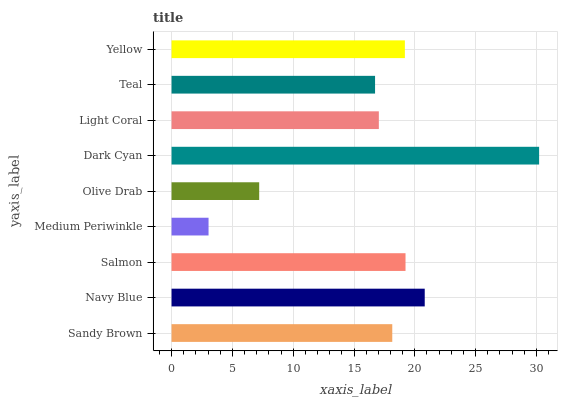Is Medium Periwinkle the minimum?
Answer yes or no. Yes. Is Dark Cyan the maximum?
Answer yes or no. Yes. Is Navy Blue the minimum?
Answer yes or no. No. Is Navy Blue the maximum?
Answer yes or no. No. Is Navy Blue greater than Sandy Brown?
Answer yes or no. Yes. Is Sandy Brown less than Navy Blue?
Answer yes or no. Yes. Is Sandy Brown greater than Navy Blue?
Answer yes or no. No. Is Navy Blue less than Sandy Brown?
Answer yes or no. No. Is Sandy Brown the high median?
Answer yes or no. Yes. Is Sandy Brown the low median?
Answer yes or no. Yes. Is Teal the high median?
Answer yes or no. No. Is Salmon the low median?
Answer yes or no. No. 